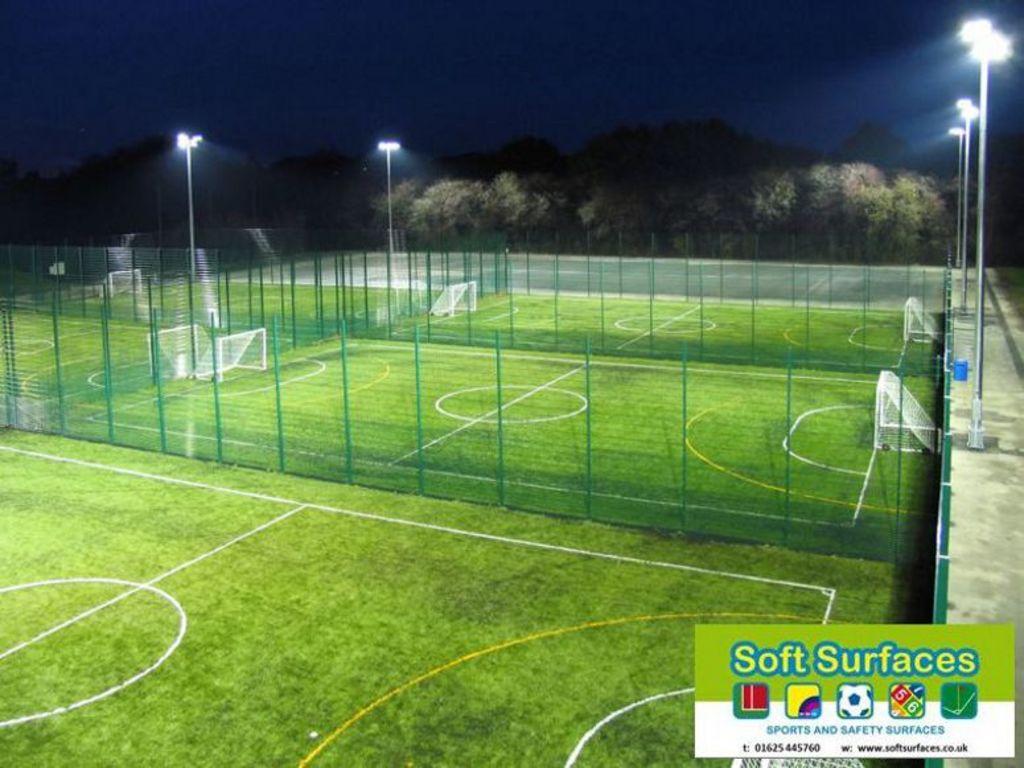What kind of surfaces?
Your answer should be very brief. Soft. What is soft surfaces' website?
Your response must be concise. Www.softsurfaces.co.uk. 